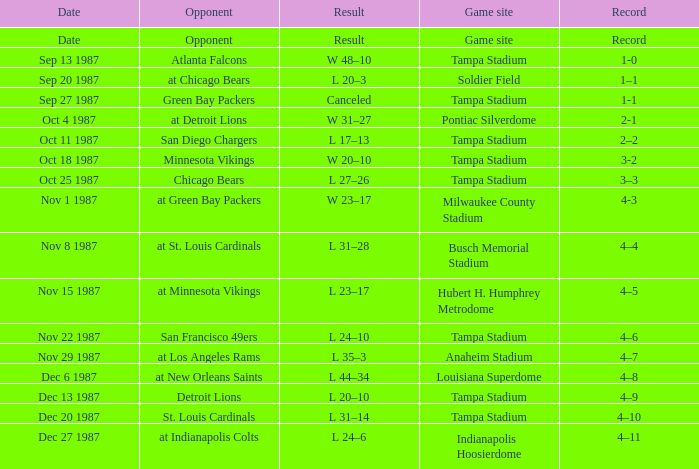Who was the Opponent at the Game Site Indianapolis Hoosierdome? At indianapolis colts. 